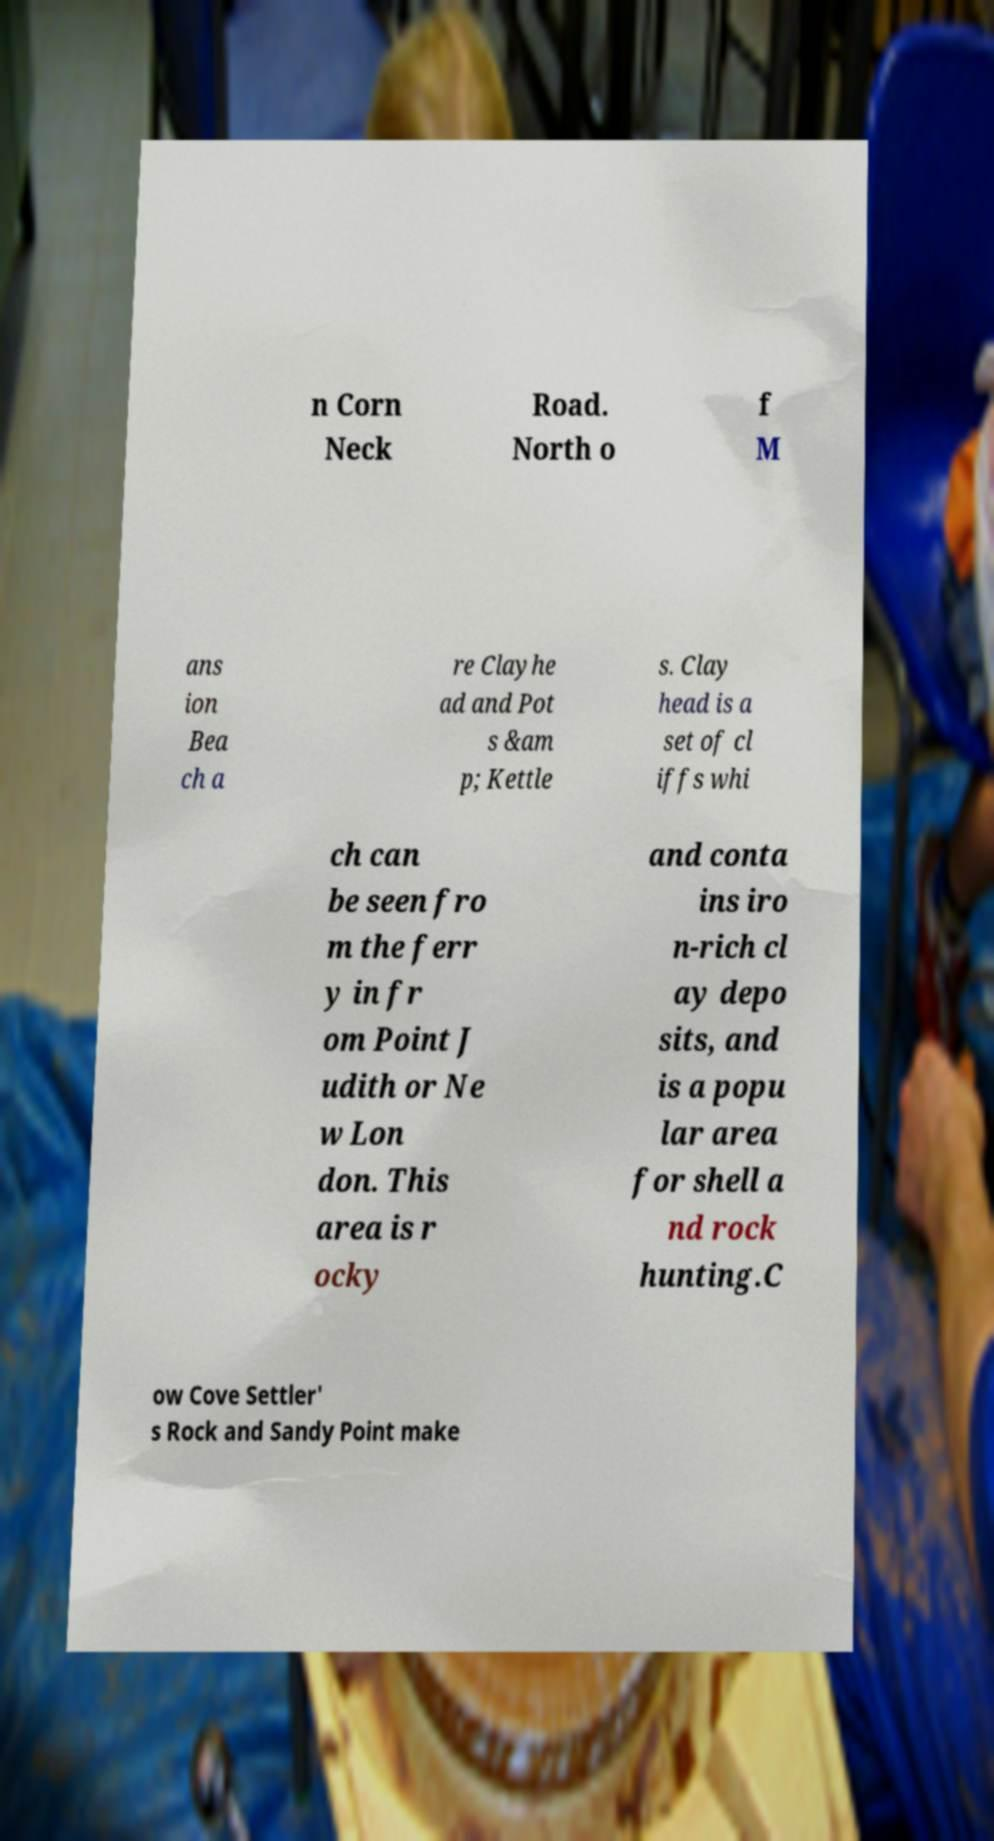Can you accurately transcribe the text from the provided image for me? n Corn Neck Road. North o f M ans ion Bea ch a re Clayhe ad and Pot s &am p; Kettle s. Clay head is a set of cl iffs whi ch can be seen fro m the ferr y in fr om Point J udith or Ne w Lon don. This area is r ocky and conta ins iro n-rich cl ay depo sits, and is a popu lar area for shell a nd rock hunting.C ow Cove Settler' s Rock and Sandy Point make 